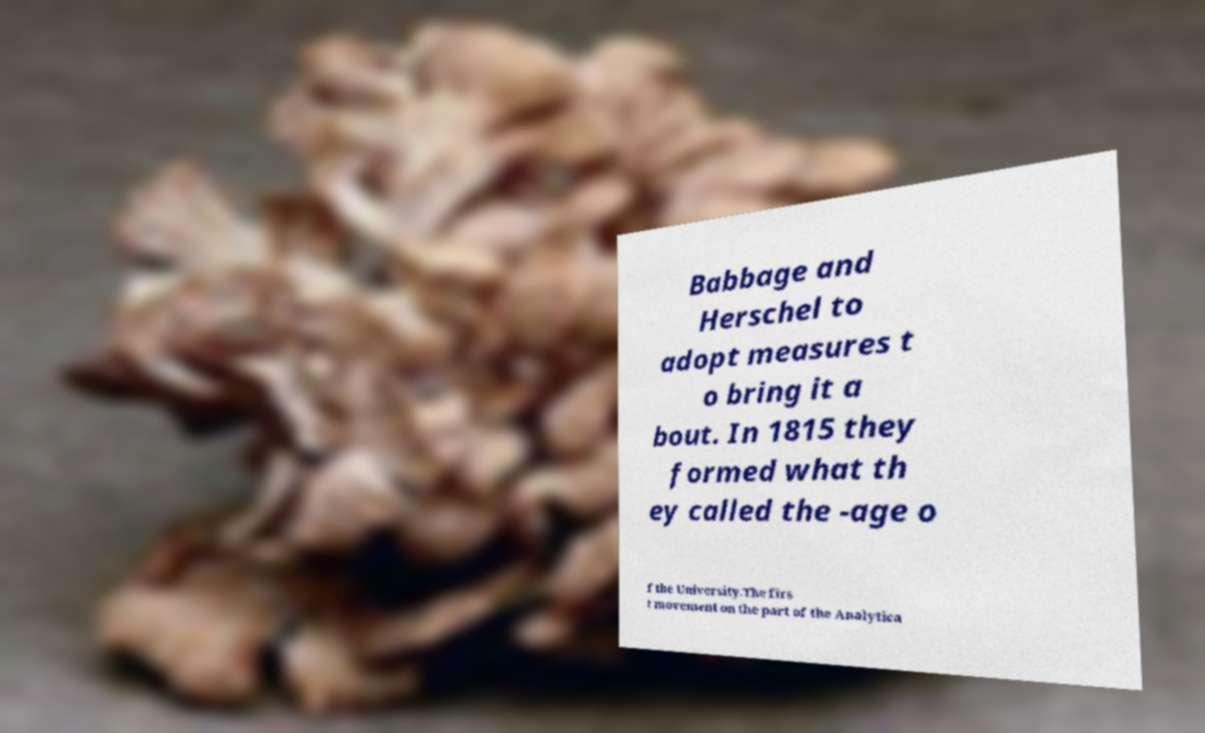I need the written content from this picture converted into text. Can you do that? Babbage and Herschel to adopt measures t o bring it a bout. In 1815 they formed what th ey called the -age o f the University.The firs t movement on the part of the Analytica 